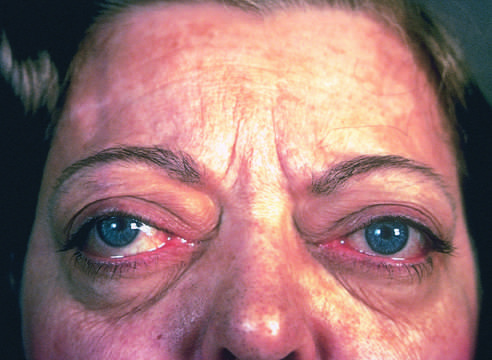s borderline serous cystadenoma one of the classic features of this disorder?
Answer the question using a single word or phrase. No 